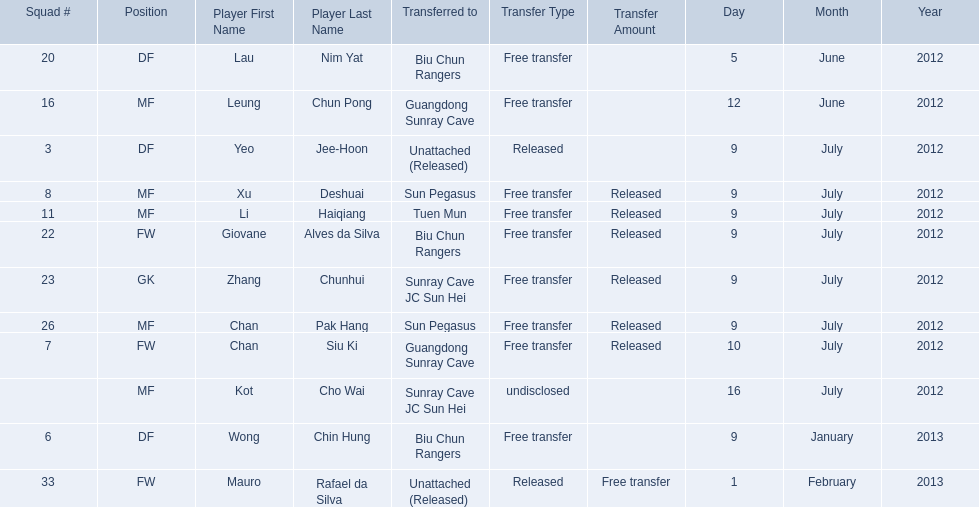Which players played during the 2012-13 south china aa season? Lau Nim Yat, Leung Chun Pong, Yeo Jee-Hoon, Xu Deshuai, Li Haiqiang, Giovane Alves da Silva, Zhang Chunhui, Chan Pak Hang, Chan Siu Ki, Kot Cho Wai, Wong Chin Hung, Mauro Rafael da Silva. Of these, which were free transfers that were not released? Lau Nim Yat, Leung Chun Pong, Wong Chin Hung, Mauro Rafael da Silva. Of these, which were in squad # 6? Wong Chin Hung. What was the date of his transfer? 9 January 2013. 